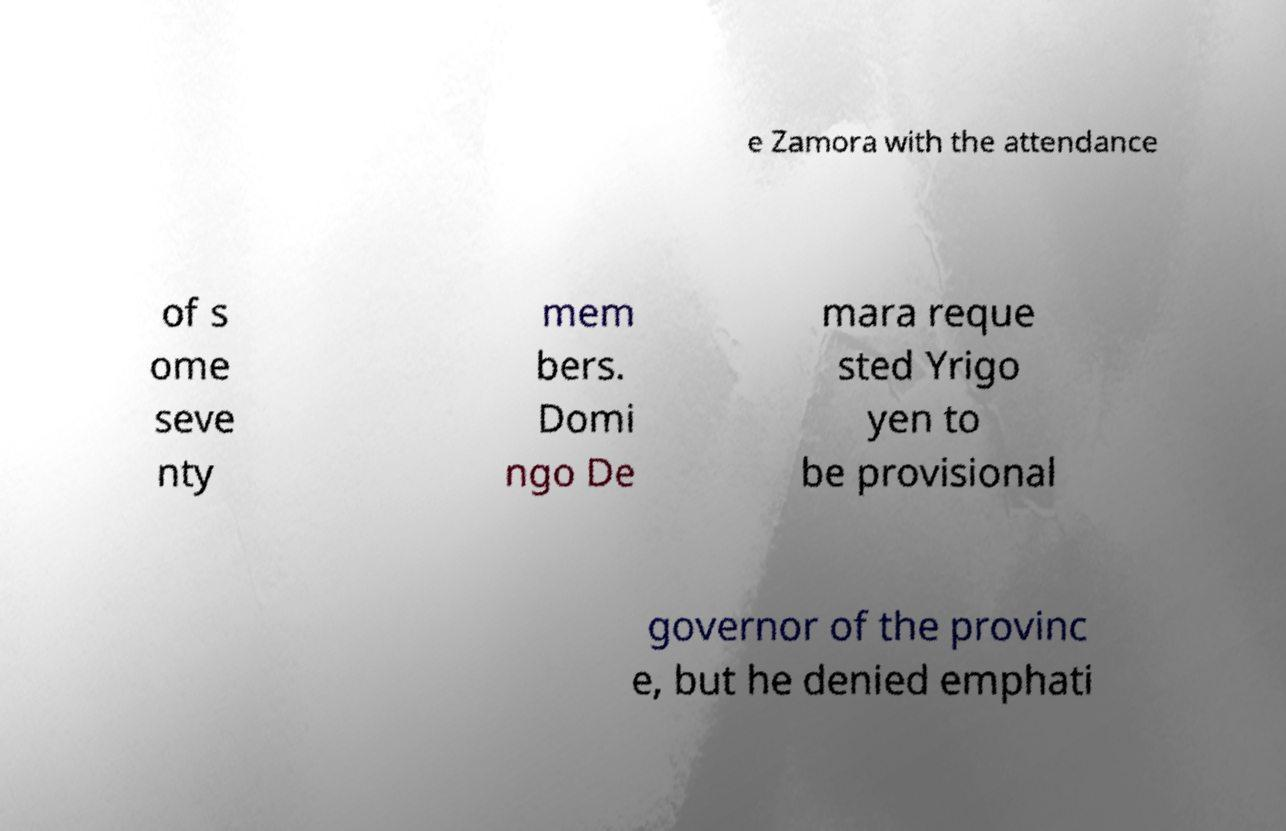Please identify and transcribe the text found in this image. e Zamora with the attendance of s ome seve nty mem bers. Domi ngo De mara reque sted Yrigo yen to be provisional governor of the provinc e, but he denied emphati 